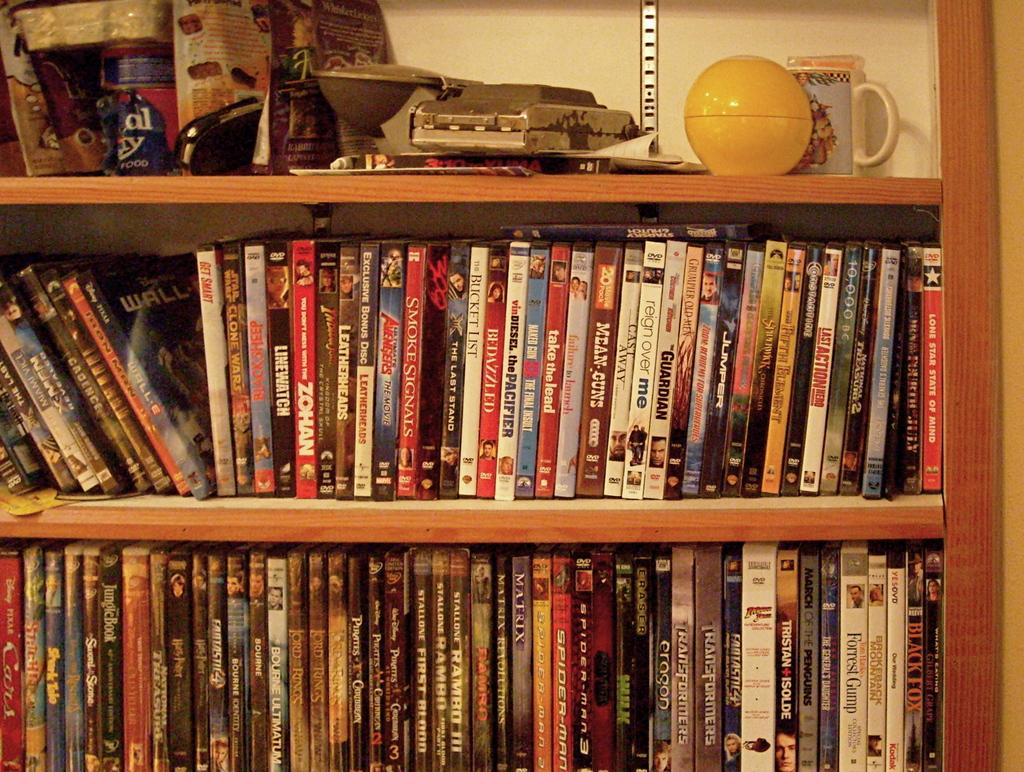<image>
Provide a brief description of the given image. Bedazzled bunched in with other books on a shelf. 